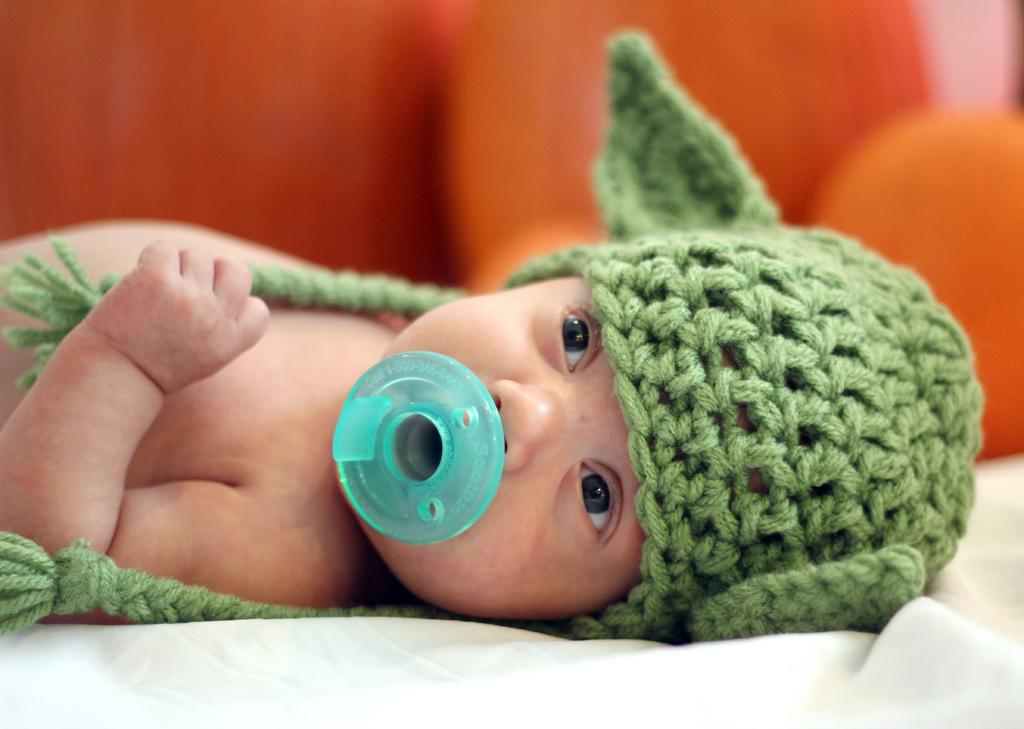What is the main subject of the image? There is a baby in the image. What is the baby's position in the image? The baby is lying down. What is the baby wearing on their head? The baby is wearing a green cap. Can you describe the background of the image? The background of the image is blurred. What type of coat is the baby wearing in the image? The baby is not wearing a coat in the image; they are wearing a green cap. Can you see any plants in the background of the image? There are no plants visible in the image; the background is blurred. 